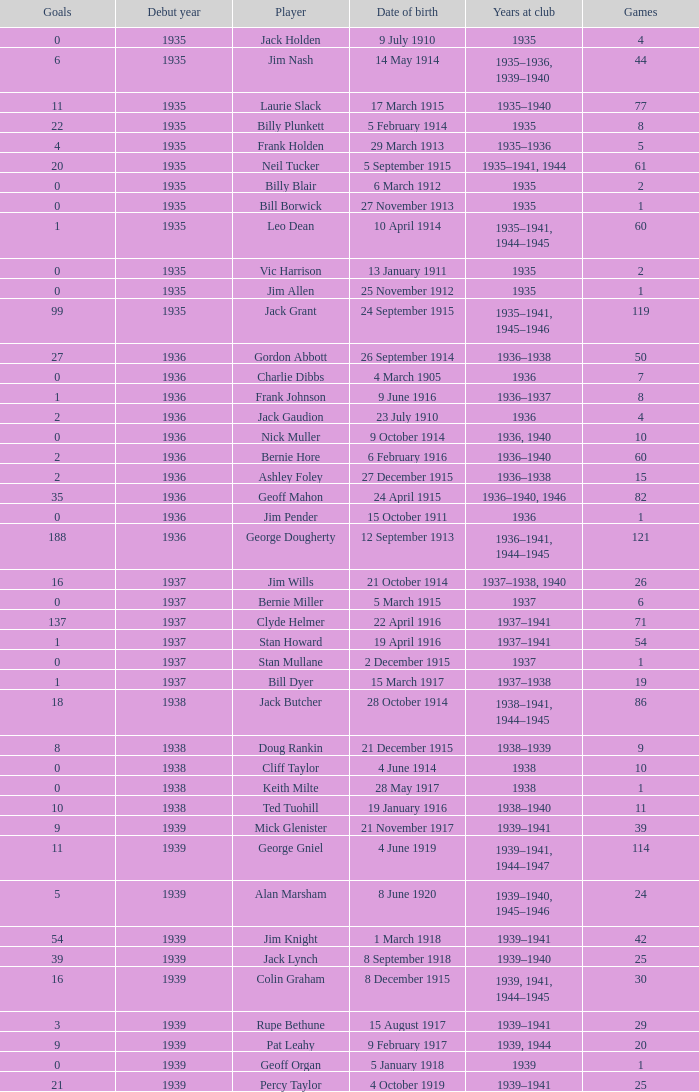How many games had 22 goals before 1935? None. 